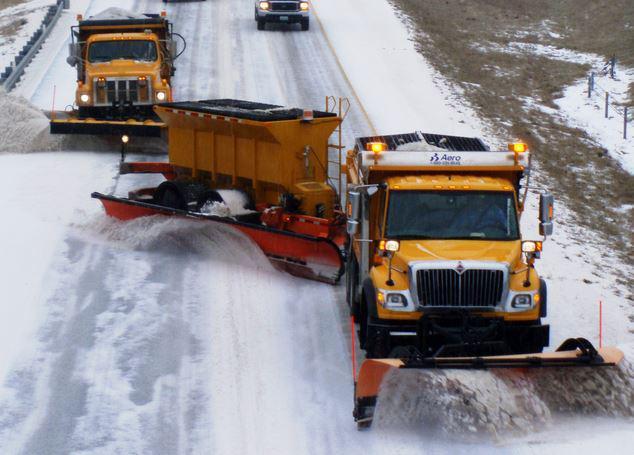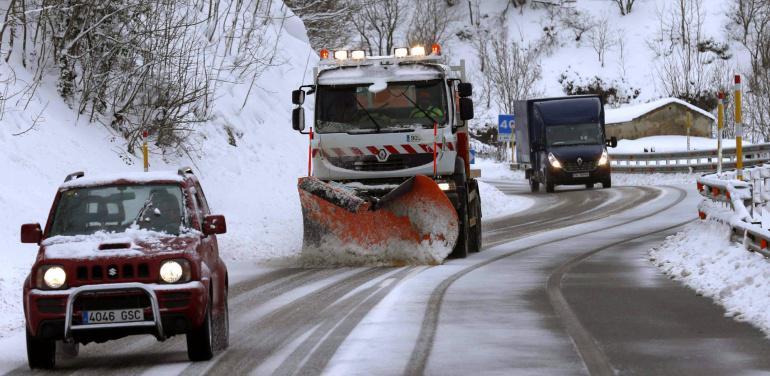The first image is the image on the left, the second image is the image on the right. Given the left and right images, does the statement "There are two or more trucks in the right image." hold true? Answer yes or no. Yes. The first image is the image on the left, the second image is the image on the right. Evaluate the accuracy of this statement regarding the images: "The left image shows a red truck with a red plow on its front, pushing snow and headed toward the camera.". Is it true? Answer yes or no. No. 